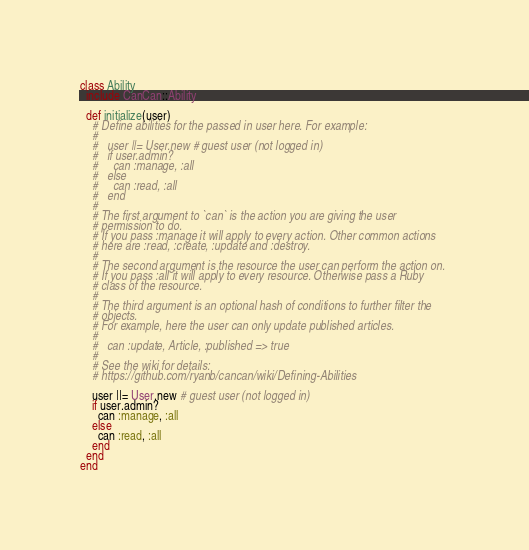<code> <loc_0><loc_0><loc_500><loc_500><_Ruby_>class Ability
  include CanCan::Ability

  def initialize(user)
    # Define abilities for the passed in user here. For example:
    #
    #   user ||= User.new # guest user (not logged in)
    #   if user.admin?
    #     can :manage, :all
    #   else
    #     can :read, :all
    #   end
    #
    # The first argument to `can` is the action you are giving the user 
    # permission to do.
    # If you pass :manage it will apply to every action. Other common actions
    # here are :read, :create, :update and :destroy.
    #
    # The second argument is the resource the user can perform the action on. 
    # If you pass :all it will apply to every resource. Otherwise pass a Ruby
    # class of the resource.
    #
    # The third argument is an optional hash of conditions to further filter the
    # objects.
    # For example, here the user can only update published articles.
    #
    #   can :update, Article, :published => true
    #
    # See the wiki for details:
    # https://github.com/ryanb/cancan/wiki/Defining-Abilities

    user ||= User.new # guest user (not logged in)
    if user.admin?
      can :manage, :all
    else
      can :read, :all
    end
  end
end
</code> 